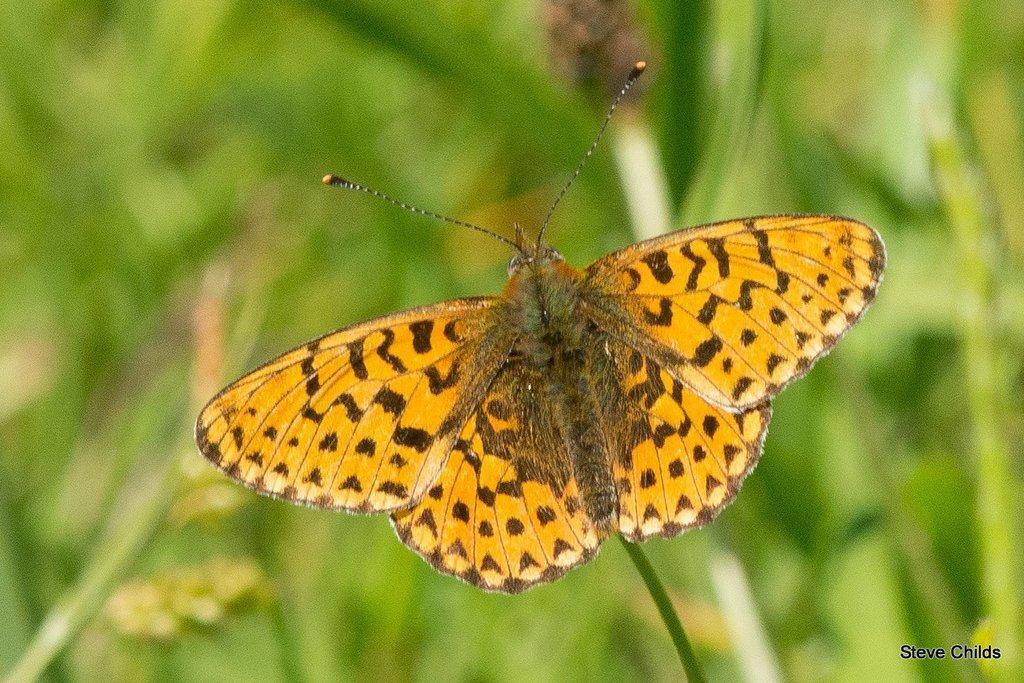Describe this image in one or two sentences. There is a picture of a butterfly as we can see in the middle of this image. There is a text at the bottom right corner. 